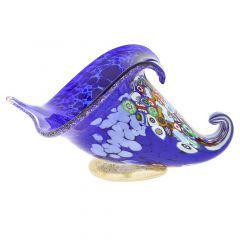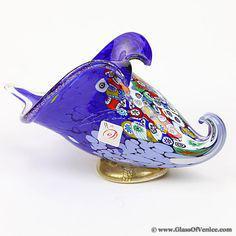The first image is the image on the left, the second image is the image on the right. Given the left and right images, does the statement "An image shows one translucent blue vase with a deep blue non-scalloped base." hold true? Answer yes or no. No. The first image is the image on the left, the second image is the image on the right. Examine the images to the left and right. Is the description "there are blue glass vases with black bottoms" accurate? Answer yes or no. No. 